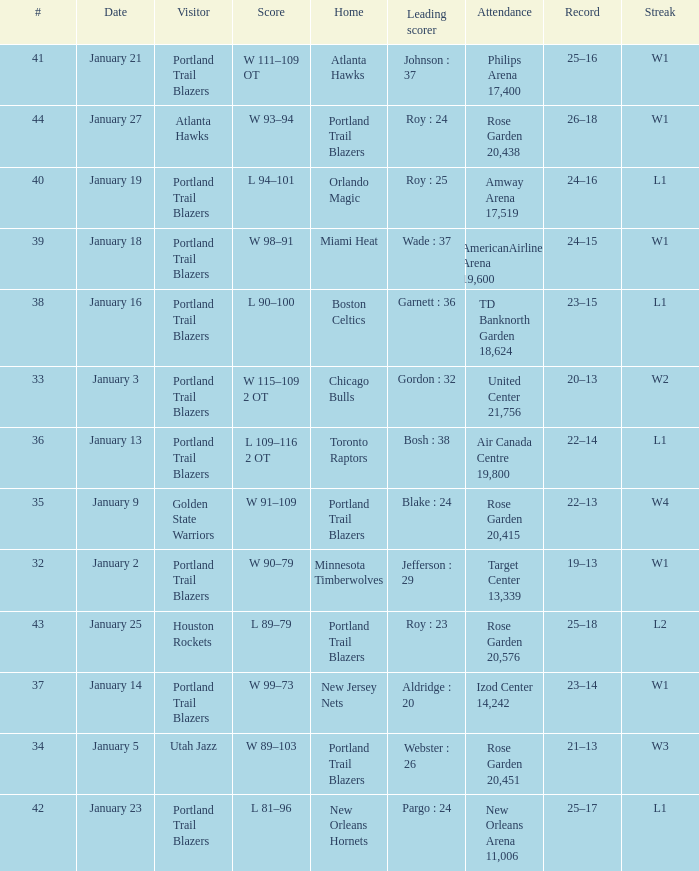What records have a score of l 109–116 2 ot 22–14. 